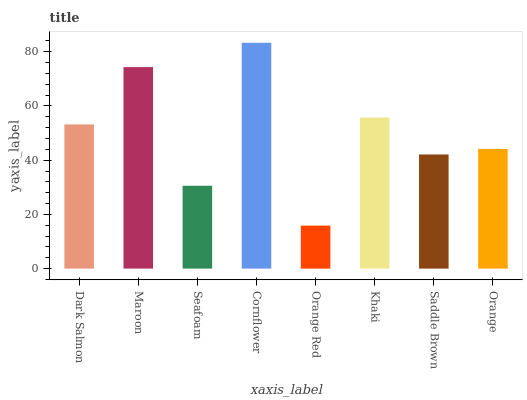Is Orange Red the minimum?
Answer yes or no. Yes. Is Cornflower the maximum?
Answer yes or no. Yes. Is Maroon the minimum?
Answer yes or no. No. Is Maroon the maximum?
Answer yes or no. No. Is Maroon greater than Dark Salmon?
Answer yes or no. Yes. Is Dark Salmon less than Maroon?
Answer yes or no. Yes. Is Dark Salmon greater than Maroon?
Answer yes or no. No. Is Maroon less than Dark Salmon?
Answer yes or no. No. Is Dark Salmon the high median?
Answer yes or no. Yes. Is Orange the low median?
Answer yes or no. Yes. Is Orange Red the high median?
Answer yes or no. No. Is Cornflower the low median?
Answer yes or no. No. 